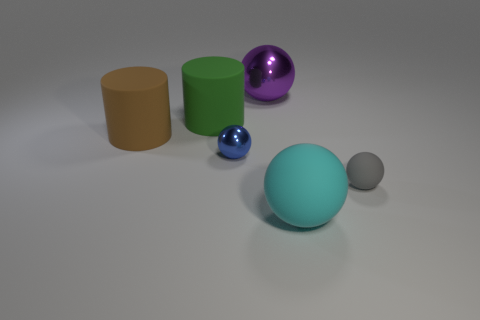Are the big green cylinder and the tiny thing that is in front of the blue metallic ball made of the same material?
Ensure brevity in your answer.  Yes. There is a large sphere in front of the tiny object that is on the right side of the matte thing that is in front of the small gray matte sphere; what color is it?
Your response must be concise. Cyan. Are there any other things that are the same size as the purple metallic thing?
Offer a terse response. Yes. Does the small shiny ball have the same color as the large matte cylinder to the left of the green cylinder?
Offer a very short reply. No. What color is the small rubber sphere?
Your answer should be very brief. Gray. What is the shape of the metal object in front of the metallic object that is behind the sphere that is on the left side of the large purple metal object?
Give a very brief answer. Sphere. What number of other objects are the same color as the small metal ball?
Provide a succinct answer. 0. Are there more gray rubber spheres on the left side of the small metal object than tiny spheres that are right of the tiny gray sphere?
Your answer should be very brief. No. Are there any things to the left of the gray sphere?
Provide a short and direct response. Yes. What is the ball that is in front of the large metallic object and behind the tiny gray thing made of?
Make the answer very short. Metal. 